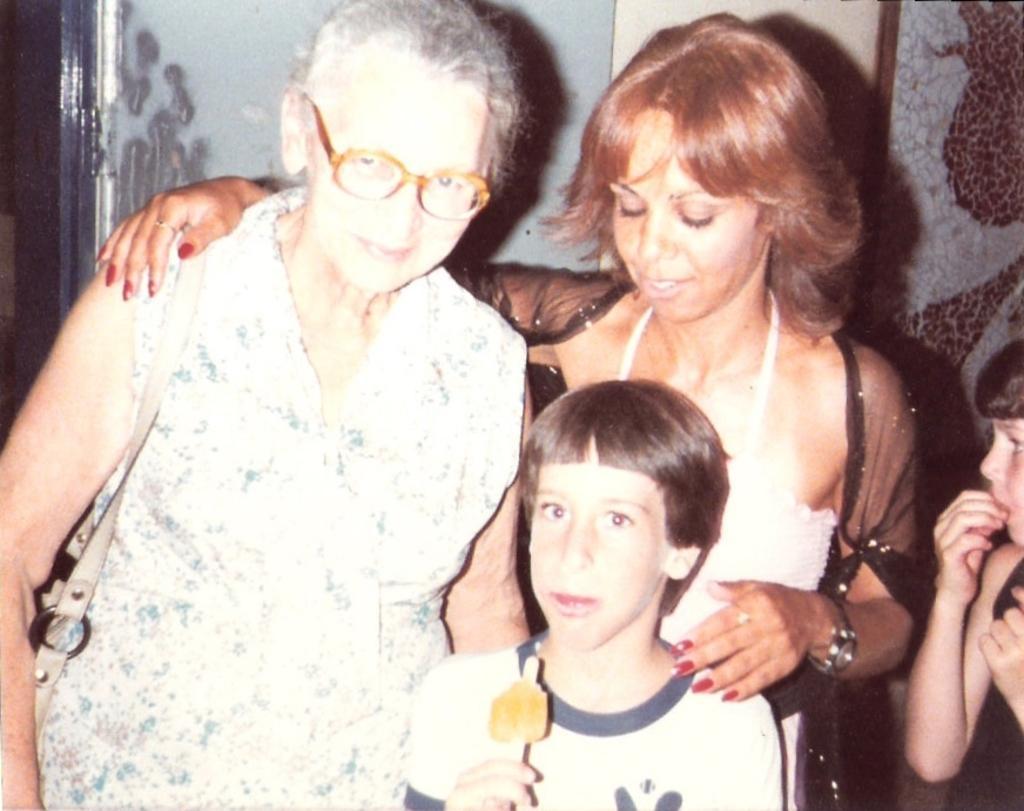Could you give a brief overview of what you see in this image? In this picture, we can see a few people, and among them a person is holding some object, we can see the wall. 